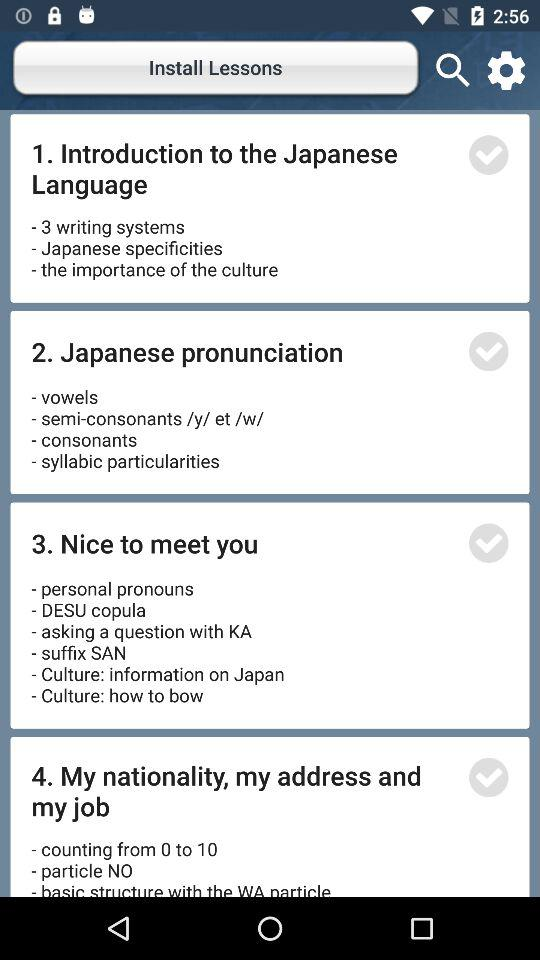What are the contents of the lesson "Introduction to the Japanese Language"? The contents of the lesson "Introduction to the Japanese Language" are "3 writing systems", "Japanese specificities" and "the importance of the culture". 